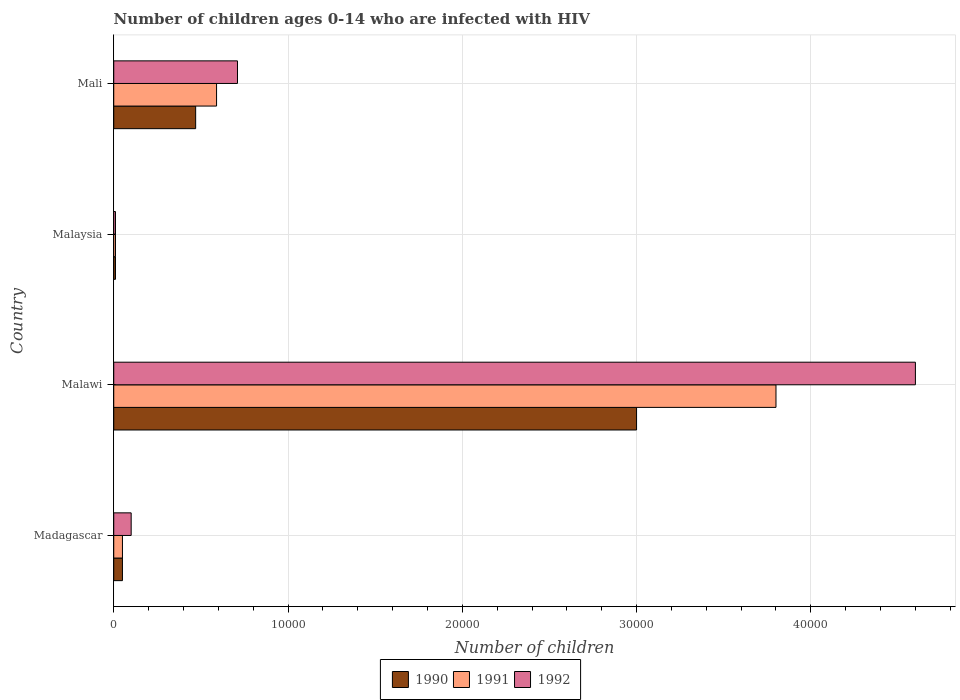How many groups of bars are there?
Keep it short and to the point. 4. Are the number of bars on each tick of the Y-axis equal?
Your answer should be compact. Yes. How many bars are there on the 3rd tick from the top?
Provide a short and direct response. 3. How many bars are there on the 2nd tick from the bottom?
Your response must be concise. 3. What is the label of the 3rd group of bars from the top?
Ensure brevity in your answer.  Malawi. In how many cases, is the number of bars for a given country not equal to the number of legend labels?
Give a very brief answer. 0. What is the number of HIV infected children in 1991 in Malawi?
Give a very brief answer. 3.80e+04. Across all countries, what is the maximum number of HIV infected children in 1990?
Ensure brevity in your answer.  3.00e+04. Across all countries, what is the minimum number of HIV infected children in 1990?
Make the answer very short. 100. In which country was the number of HIV infected children in 1992 maximum?
Your answer should be compact. Malawi. In which country was the number of HIV infected children in 1992 minimum?
Make the answer very short. Malaysia. What is the total number of HIV infected children in 1991 in the graph?
Offer a terse response. 4.45e+04. What is the difference between the number of HIV infected children in 1990 in Malaysia and that in Mali?
Give a very brief answer. -4600. What is the difference between the number of HIV infected children in 1990 in Malawi and the number of HIV infected children in 1991 in Malaysia?
Your answer should be very brief. 2.99e+04. What is the average number of HIV infected children in 1990 per country?
Make the answer very short. 8825. What is the difference between the number of HIV infected children in 1991 and number of HIV infected children in 1992 in Madagascar?
Provide a succinct answer. -500. What is the ratio of the number of HIV infected children in 1990 in Madagascar to that in Malaysia?
Your response must be concise. 5. What is the difference between the highest and the second highest number of HIV infected children in 1992?
Give a very brief answer. 3.89e+04. What is the difference between the highest and the lowest number of HIV infected children in 1991?
Offer a terse response. 3.79e+04. Is the sum of the number of HIV infected children in 1991 in Malaysia and Mali greater than the maximum number of HIV infected children in 1990 across all countries?
Offer a very short reply. No. What does the 2nd bar from the top in Malaysia represents?
Your answer should be very brief. 1991. How many bars are there?
Your answer should be compact. 12. Are all the bars in the graph horizontal?
Give a very brief answer. Yes. What is the difference between two consecutive major ticks on the X-axis?
Ensure brevity in your answer.  10000. Does the graph contain any zero values?
Keep it short and to the point. No. Where does the legend appear in the graph?
Provide a succinct answer. Bottom center. How many legend labels are there?
Ensure brevity in your answer.  3. How are the legend labels stacked?
Offer a terse response. Horizontal. What is the title of the graph?
Your answer should be compact. Number of children ages 0-14 who are infected with HIV. Does "1980" appear as one of the legend labels in the graph?
Offer a very short reply. No. What is the label or title of the X-axis?
Your response must be concise. Number of children. What is the Number of children of 1990 in Madagascar?
Provide a succinct answer. 500. What is the Number of children of 1992 in Madagascar?
Provide a succinct answer. 1000. What is the Number of children of 1990 in Malawi?
Ensure brevity in your answer.  3.00e+04. What is the Number of children of 1991 in Malawi?
Provide a succinct answer. 3.80e+04. What is the Number of children in 1992 in Malawi?
Offer a terse response. 4.60e+04. What is the Number of children in 1991 in Malaysia?
Your answer should be compact. 100. What is the Number of children in 1990 in Mali?
Provide a succinct answer. 4700. What is the Number of children of 1991 in Mali?
Your answer should be compact. 5900. What is the Number of children in 1992 in Mali?
Give a very brief answer. 7100. Across all countries, what is the maximum Number of children of 1991?
Your answer should be compact. 3.80e+04. Across all countries, what is the maximum Number of children in 1992?
Offer a very short reply. 4.60e+04. Across all countries, what is the minimum Number of children in 1991?
Ensure brevity in your answer.  100. Across all countries, what is the minimum Number of children of 1992?
Your answer should be compact. 100. What is the total Number of children in 1990 in the graph?
Offer a terse response. 3.53e+04. What is the total Number of children in 1991 in the graph?
Provide a succinct answer. 4.45e+04. What is the total Number of children in 1992 in the graph?
Your response must be concise. 5.42e+04. What is the difference between the Number of children in 1990 in Madagascar and that in Malawi?
Provide a short and direct response. -2.95e+04. What is the difference between the Number of children in 1991 in Madagascar and that in Malawi?
Keep it short and to the point. -3.75e+04. What is the difference between the Number of children in 1992 in Madagascar and that in Malawi?
Keep it short and to the point. -4.50e+04. What is the difference between the Number of children in 1992 in Madagascar and that in Malaysia?
Ensure brevity in your answer.  900. What is the difference between the Number of children of 1990 in Madagascar and that in Mali?
Offer a terse response. -4200. What is the difference between the Number of children of 1991 in Madagascar and that in Mali?
Your answer should be very brief. -5400. What is the difference between the Number of children in 1992 in Madagascar and that in Mali?
Your answer should be compact. -6100. What is the difference between the Number of children in 1990 in Malawi and that in Malaysia?
Keep it short and to the point. 2.99e+04. What is the difference between the Number of children in 1991 in Malawi and that in Malaysia?
Your response must be concise. 3.79e+04. What is the difference between the Number of children of 1992 in Malawi and that in Malaysia?
Offer a very short reply. 4.59e+04. What is the difference between the Number of children in 1990 in Malawi and that in Mali?
Keep it short and to the point. 2.53e+04. What is the difference between the Number of children of 1991 in Malawi and that in Mali?
Offer a terse response. 3.21e+04. What is the difference between the Number of children of 1992 in Malawi and that in Mali?
Provide a short and direct response. 3.89e+04. What is the difference between the Number of children in 1990 in Malaysia and that in Mali?
Offer a terse response. -4600. What is the difference between the Number of children in 1991 in Malaysia and that in Mali?
Provide a succinct answer. -5800. What is the difference between the Number of children in 1992 in Malaysia and that in Mali?
Your response must be concise. -7000. What is the difference between the Number of children in 1990 in Madagascar and the Number of children in 1991 in Malawi?
Ensure brevity in your answer.  -3.75e+04. What is the difference between the Number of children of 1990 in Madagascar and the Number of children of 1992 in Malawi?
Offer a terse response. -4.55e+04. What is the difference between the Number of children of 1991 in Madagascar and the Number of children of 1992 in Malawi?
Make the answer very short. -4.55e+04. What is the difference between the Number of children in 1991 in Madagascar and the Number of children in 1992 in Malaysia?
Provide a short and direct response. 400. What is the difference between the Number of children in 1990 in Madagascar and the Number of children in 1991 in Mali?
Keep it short and to the point. -5400. What is the difference between the Number of children in 1990 in Madagascar and the Number of children in 1992 in Mali?
Your answer should be very brief. -6600. What is the difference between the Number of children in 1991 in Madagascar and the Number of children in 1992 in Mali?
Offer a very short reply. -6600. What is the difference between the Number of children of 1990 in Malawi and the Number of children of 1991 in Malaysia?
Keep it short and to the point. 2.99e+04. What is the difference between the Number of children in 1990 in Malawi and the Number of children in 1992 in Malaysia?
Make the answer very short. 2.99e+04. What is the difference between the Number of children in 1991 in Malawi and the Number of children in 1992 in Malaysia?
Ensure brevity in your answer.  3.79e+04. What is the difference between the Number of children of 1990 in Malawi and the Number of children of 1991 in Mali?
Make the answer very short. 2.41e+04. What is the difference between the Number of children in 1990 in Malawi and the Number of children in 1992 in Mali?
Ensure brevity in your answer.  2.29e+04. What is the difference between the Number of children in 1991 in Malawi and the Number of children in 1992 in Mali?
Provide a succinct answer. 3.09e+04. What is the difference between the Number of children of 1990 in Malaysia and the Number of children of 1991 in Mali?
Give a very brief answer. -5800. What is the difference between the Number of children in 1990 in Malaysia and the Number of children in 1992 in Mali?
Keep it short and to the point. -7000. What is the difference between the Number of children of 1991 in Malaysia and the Number of children of 1992 in Mali?
Provide a short and direct response. -7000. What is the average Number of children in 1990 per country?
Your answer should be compact. 8825. What is the average Number of children in 1991 per country?
Give a very brief answer. 1.11e+04. What is the average Number of children in 1992 per country?
Your response must be concise. 1.36e+04. What is the difference between the Number of children of 1990 and Number of children of 1992 in Madagascar?
Your response must be concise. -500. What is the difference between the Number of children of 1991 and Number of children of 1992 in Madagascar?
Offer a terse response. -500. What is the difference between the Number of children in 1990 and Number of children in 1991 in Malawi?
Offer a terse response. -8000. What is the difference between the Number of children of 1990 and Number of children of 1992 in Malawi?
Your response must be concise. -1.60e+04. What is the difference between the Number of children in 1991 and Number of children in 1992 in Malawi?
Your response must be concise. -8000. What is the difference between the Number of children in 1990 and Number of children in 1991 in Malaysia?
Ensure brevity in your answer.  0. What is the difference between the Number of children in 1990 and Number of children in 1991 in Mali?
Keep it short and to the point. -1200. What is the difference between the Number of children in 1990 and Number of children in 1992 in Mali?
Provide a short and direct response. -2400. What is the difference between the Number of children in 1991 and Number of children in 1992 in Mali?
Give a very brief answer. -1200. What is the ratio of the Number of children of 1990 in Madagascar to that in Malawi?
Offer a very short reply. 0.02. What is the ratio of the Number of children of 1991 in Madagascar to that in Malawi?
Keep it short and to the point. 0.01. What is the ratio of the Number of children in 1992 in Madagascar to that in Malawi?
Offer a very short reply. 0.02. What is the ratio of the Number of children of 1990 in Madagascar to that in Malaysia?
Give a very brief answer. 5. What is the ratio of the Number of children of 1991 in Madagascar to that in Malaysia?
Give a very brief answer. 5. What is the ratio of the Number of children in 1992 in Madagascar to that in Malaysia?
Your response must be concise. 10. What is the ratio of the Number of children in 1990 in Madagascar to that in Mali?
Make the answer very short. 0.11. What is the ratio of the Number of children of 1991 in Madagascar to that in Mali?
Your answer should be compact. 0.08. What is the ratio of the Number of children in 1992 in Madagascar to that in Mali?
Ensure brevity in your answer.  0.14. What is the ratio of the Number of children of 1990 in Malawi to that in Malaysia?
Your answer should be compact. 300. What is the ratio of the Number of children of 1991 in Malawi to that in Malaysia?
Offer a terse response. 380. What is the ratio of the Number of children in 1992 in Malawi to that in Malaysia?
Your answer should be very brief. 460. What is the ratio of the Number of children of 1990 in Malawi to that in Mali?
Ensure brevity in your answer.  6.38. What is the ratio of the Number of children of 1991 in Malawi to that in Mali?
Your answer should be compact. 6.44. What is the ratio of the Number of children in 1992 in Malawi to that in Mali?
Your answer should be very brief. 6.48. What is the ratio of the Number of children of 1990 in Malaysia to that in Mali?
Provide a succinct answer. 0.02. What is the ratio of the Number of children of 1991 in Malaysia to that in Mali?
Your response must be concise. 0.02. What is the ratio of the Number of children in 1992 in Malaysia to that in Mali?
Ensure brevity in your answer.  0.01. What is the difference between the highest and the second highest Number of children in 1990?
Provide a succinct answer. 2.53e+04. What is the difference between the highest and the second highest Number of children of 1991?
Your response must be concise. 3.21e+04. What is the difference between the highest and the second highest Number of children of 1992?
Offer a very short reply. 3.89e+04. What is the difference between the highest and the lowest Number of children of 1990?
Offer a terse response. 2.99e+04. What is the difference between the highest and the lowest Number of children in 1991?
Your answer should be very brief. 3.79e+04. What is the difference between the highest and the lowest Number of children of 1992?
Keep it short and to the point. 4.59e+04. 